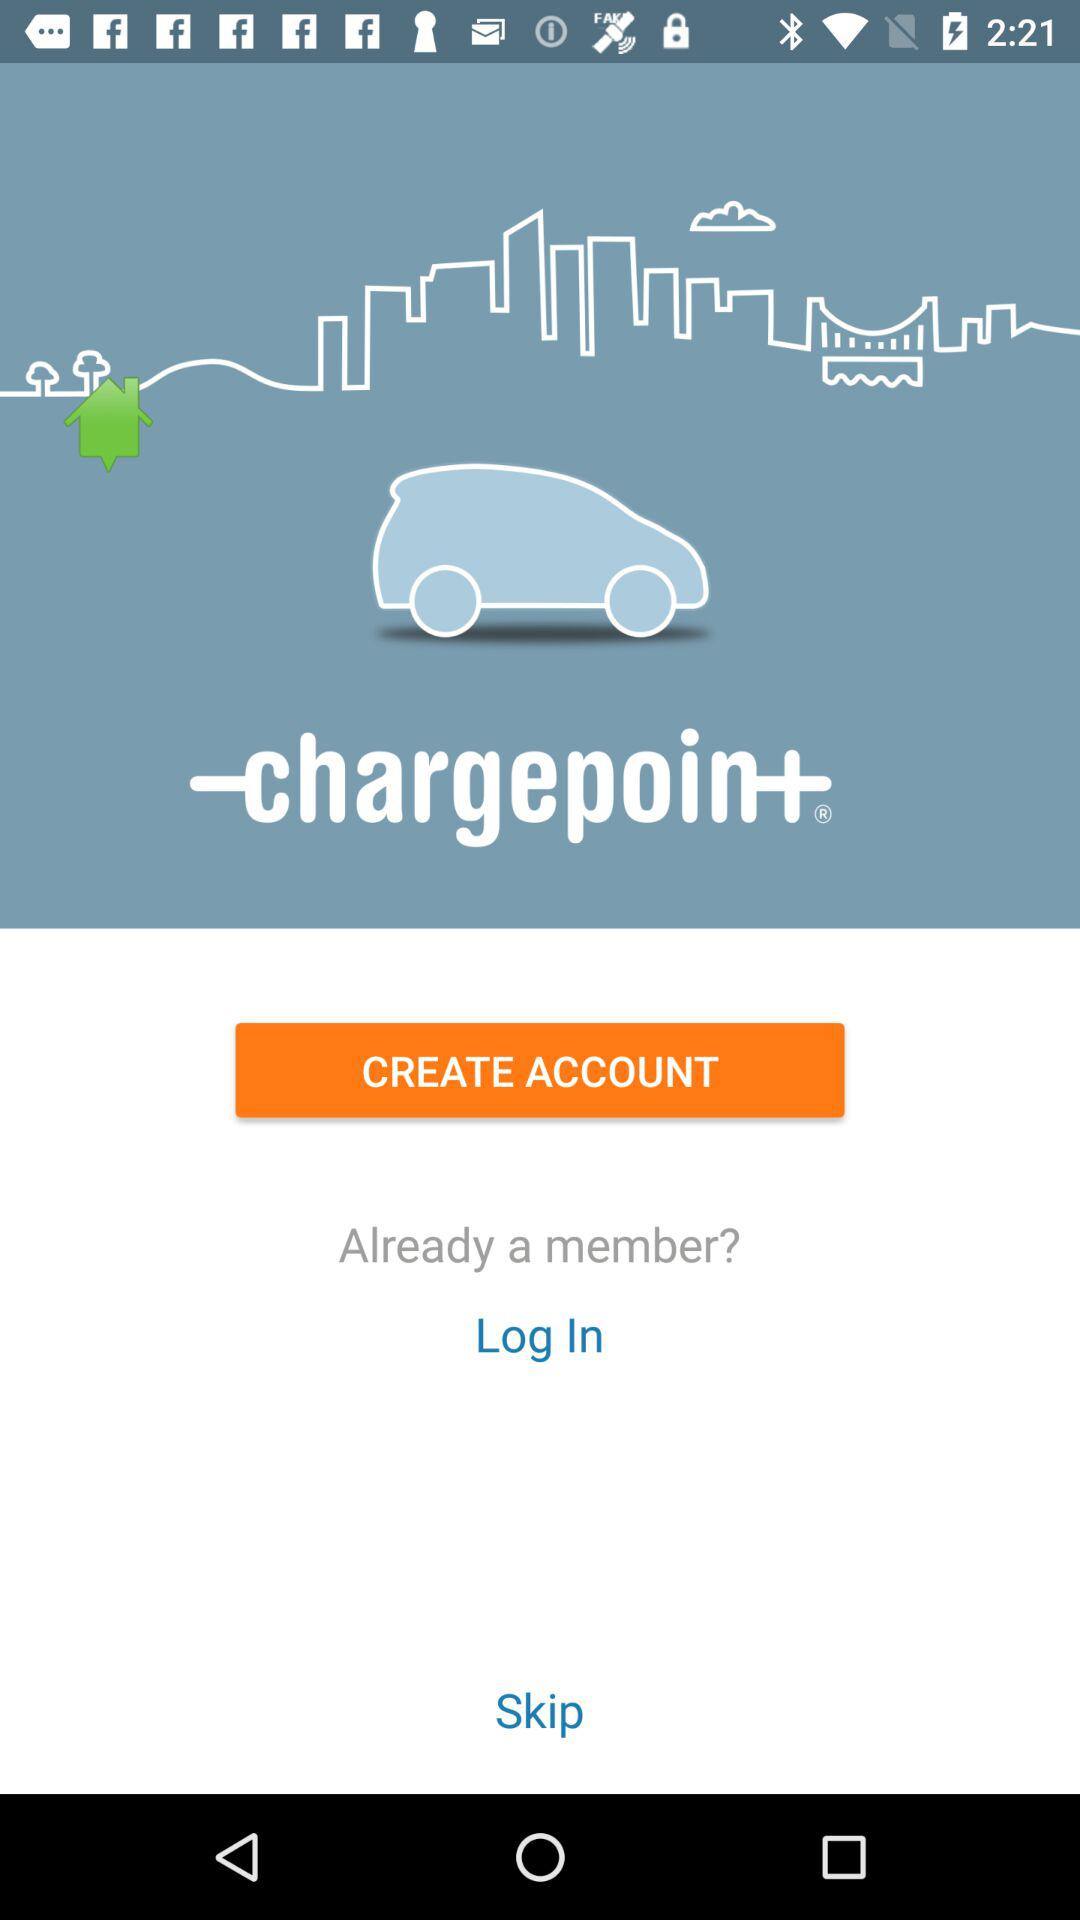What is the application name? The application name is "ChargePoint". 